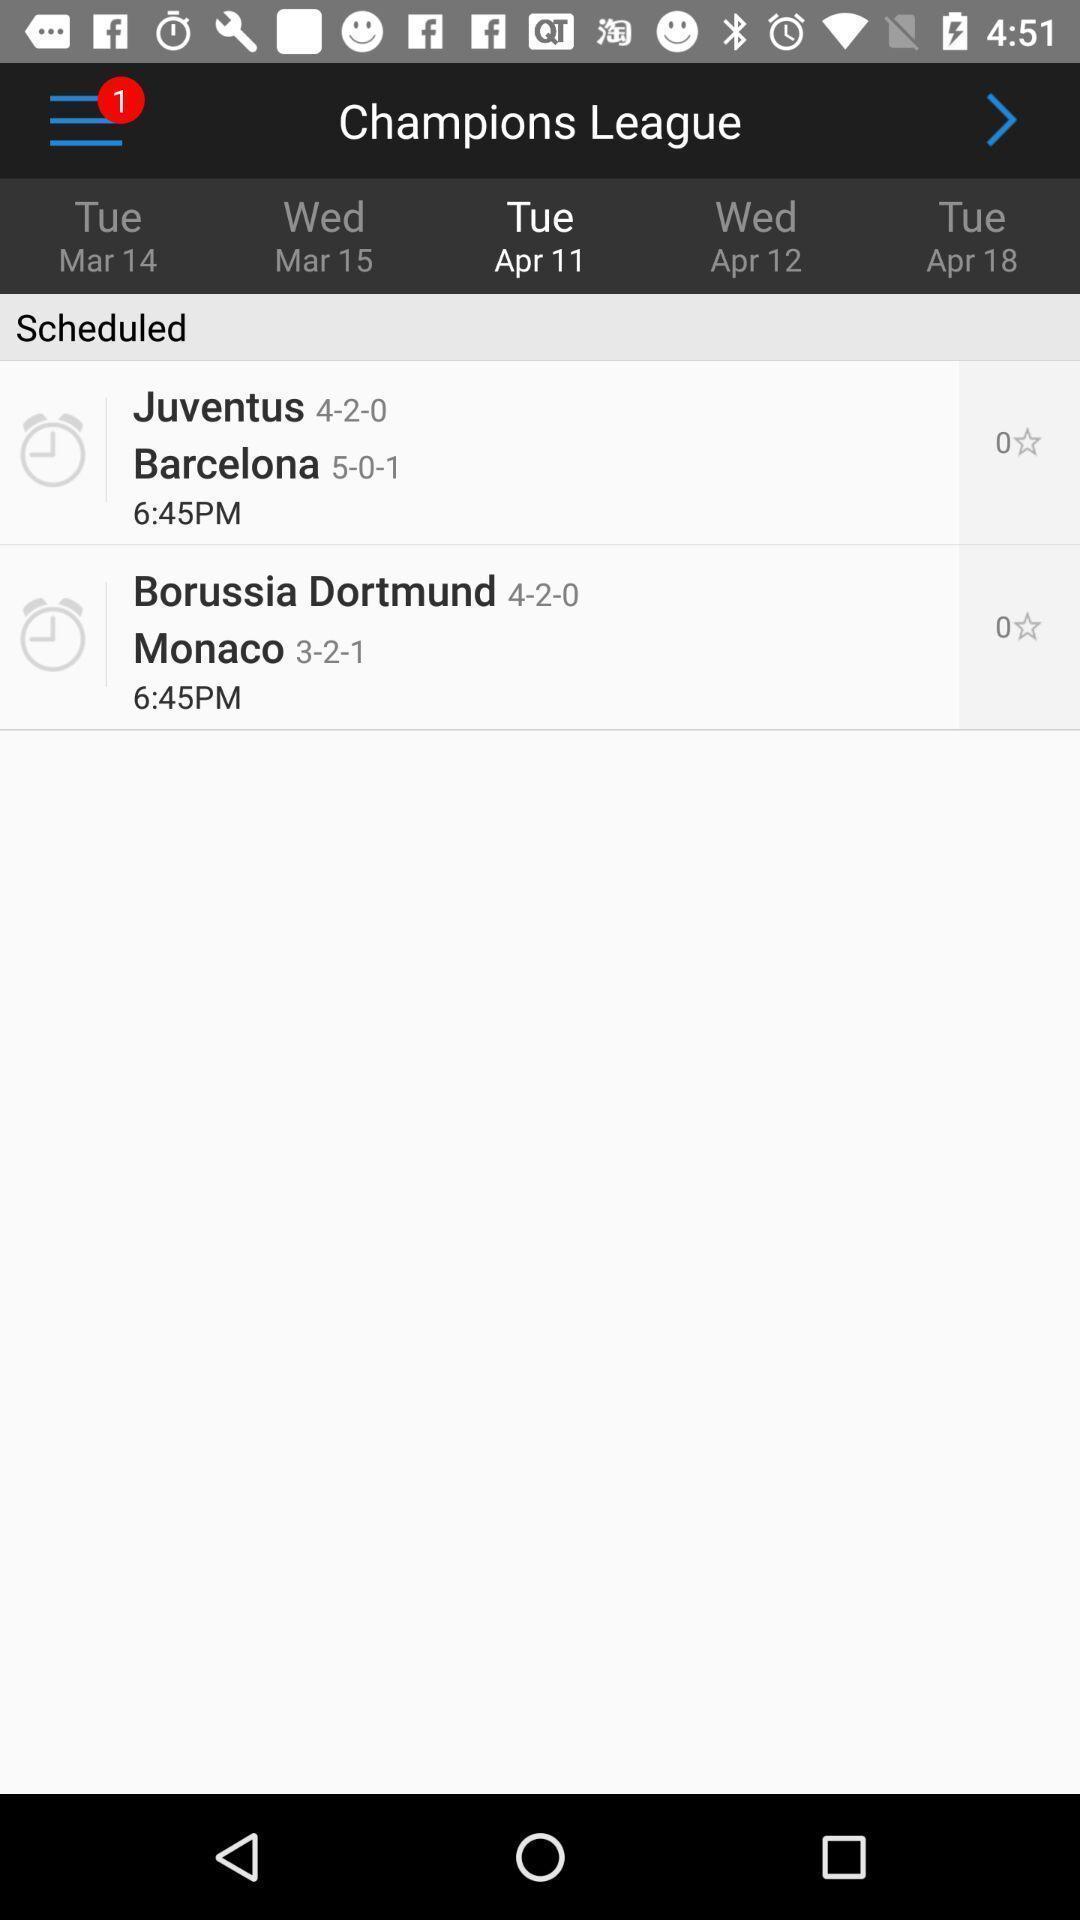Please provide a description for this image. Sport app displayed week wise different match schedules. 